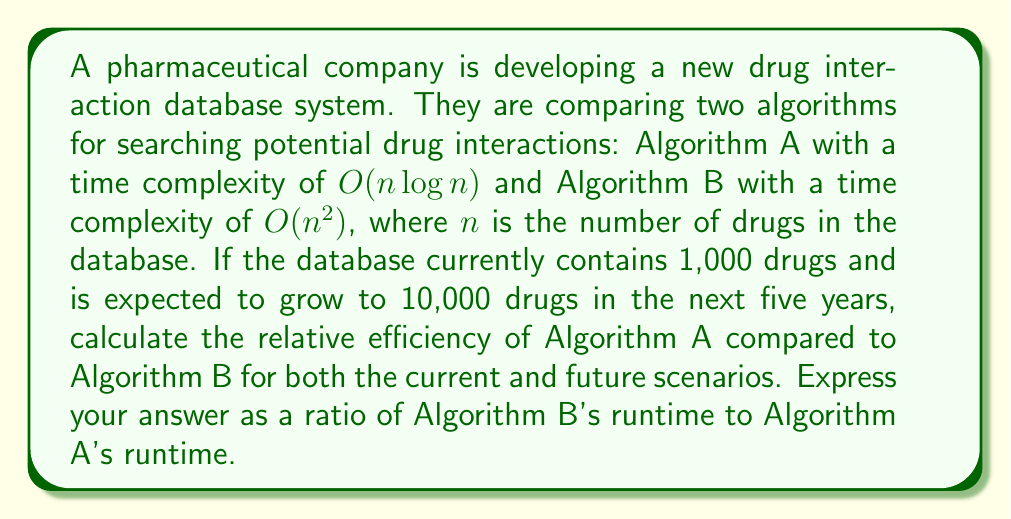What is the answer to this math problem? To solve this problem, we need to compare the time complexities of the two algorithms for both the current and future scenarios:

1. Current scenario ($n = 1,000$):
   Algorithm A: $O(n \log n) = O(1,000 \log 1,000)$
   Algorithm B: $O(n^2) = O(1,000^2)$

2. Future scenario ($n = 10,000$):
   Algorithm A: $O(n \log n) = O(10,000 \log 10,000)$
   Algorithm B: $O(n^2) = O(10,000^2)$

To compare the relative efficiency, we'll calculate the ratio of Algorithm B's runtime to Algorithm A's runtime:

$$\text{Efficiency Ratio} = \frac{\text{Runtime of Algorithm B}}{\text{Runtime of Algorithm A}} = \frac{O(n^2)}{O(n \log n)} = \frac{n^2}{n \log n} = \frac{n}{\log n}$$

For the current scenario ($n = 1,000$):
$$\text{Efficiency Ratio} = \frac{1,000}{\log 1,000} \approx 100.03$$

For the future scenario ($n = 10,000$):
$$\text{Efficiency Ratio} = \frac{10,000}{\log 10,000} \approx 752.57$$

This means that in the current scenario, Algorithm B is approximately 100 times slower than Algorithm A. In the future scenario, Algorithm B will be approximately 753 times slower than Algorithm A.
Answer: Current scenario: 100:1
Future scenario: 753:1 